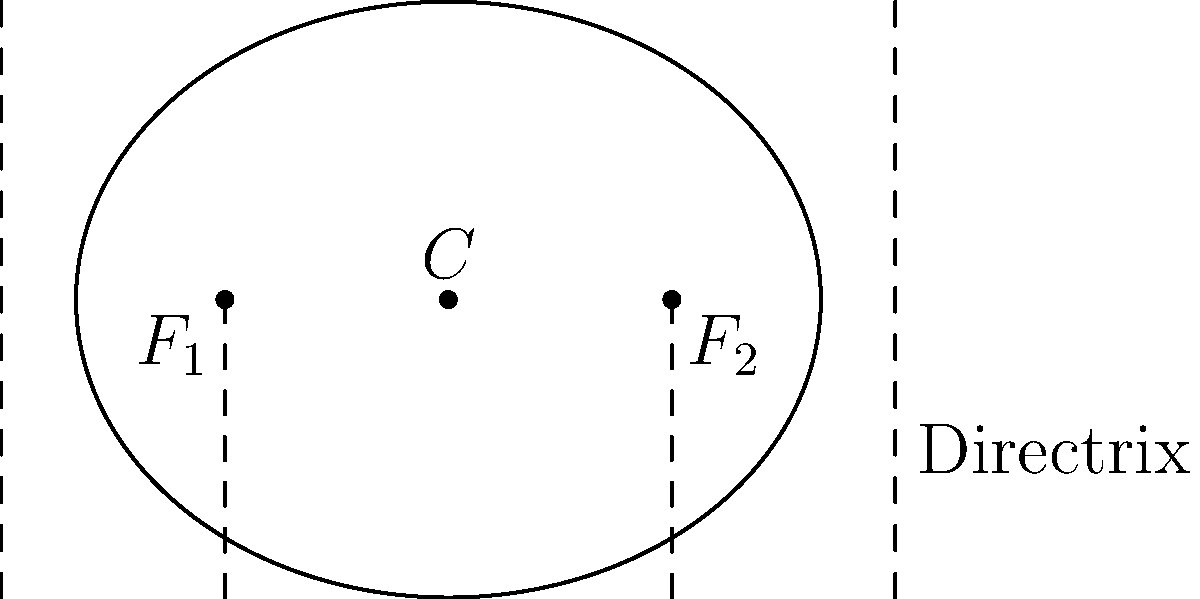In the ellipse shown, which represents the rhythm pattern of a traditional dance, the distance between the foci is 3 units, and the length of the major axis is 5 units. Find the equation of the directrix. Let's approach this step-by-step:

1) The center of the ellipse is at the origin (0,0).

2) Given:
   - Distance between foci = 3 units
   - Length of major axis = 5 units

3) Let's define our variables:
   - $a$: semi-major axis length
   - $c$: distance from center to focus
   - $e$: eccentricity

4) We can determine:
   $a = \frac{5}{2} = 2.5$ (half of the major axis length)
   $c = \frac{3}{2} = 1.5$ (half of the distance between foci)

5) Calculate eccentricity:
   $e = \frac{c}{a} = \frac{1.5}{2.5} = 0.6$

6) The equation of the directrix in an ellipse is given by:
   $x = \pm \frac{a}{e}$

7) Substituting our values:
   $x = \pm \frac{2.5}{0.6} = \pm \frac{25}{6} \approx \pm 4.17$

Therefore, the equations of the directrices are $x = \frac{25}{6}$ and $x = -\frac{25}{6}$.
Answer: $x = \pm \frac{25}{6}$ 